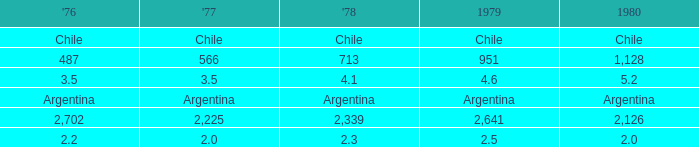What is 1976 when 1977 is 3.5? 3.5. 